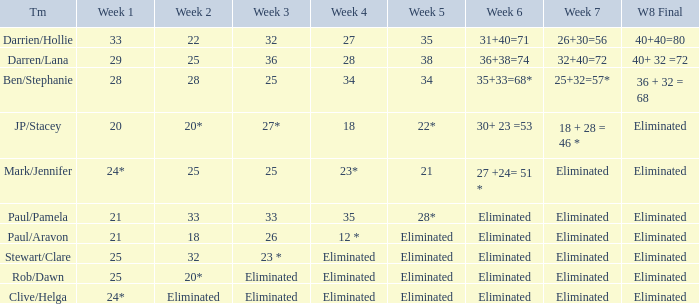Name the week 6 when week 3 is 25 and week 7 is eliminated 27 +24= 51 *. I'm looking to parse the entire table for insights. Could you assist me with that? {'header': ['Tm', 'Week 1', 'Week 2', 'Week 3', 'Week 4', 'Week 5', 'Week 6', 'Week 7', 'W8 Final'], 'rows': [['Darrien/Hollie', '33', '22', '32', '27', '35', '31+40=71', '26+30=56', '40+40=80'], ['Darren/Lana', '29', '25', '36', '28', '38', '36+38=74', '32+40=72', '40+ 32 =72'], ['Ben/Stephanie', '28', '28', '25', '34', '34', '35+33=68*', '25+32=57*', '36 + 32 = 68'], ['JP/Stacey', '20', '20*', '27*', '18', '22*', '30+ 23 =53', '18 + 28 = 46 *', 'Eliminated'], ['Mark/Jennifer', '24*', '25', '25', '23*', '21', '27 +24= 51 *', 'Eliminated', 'Eliminated'], ['Paul/Pamela', '21', '33', '33', '35', '28*', 'Eliminated', 'Eliminated', 'Eliminated'], ['Paul/Aravon', '21', '18', '26', '12 *', 'Eliminated', 'Eliminated', 'Eliminated', 'Eliminated'], ['Stewart/Clare', '25', '32', '23 *', 'Eliminated', 'Eliminated', 'Eliminated', 'Eliminated', 'Eliminated'], ['Rob/Dawn', '25', '20*', 'Eliminated', 'Eliminated', 'Eliminated', 'Eliminated', 'Eliminated', 'Eliminated'], ['Clive/Helga', '24*', 'Eliminated', 'Eliminated', 'Eliminated', 'Eliminated', 'Eliminated', 'Eliminated', 'Eliminated']]} 